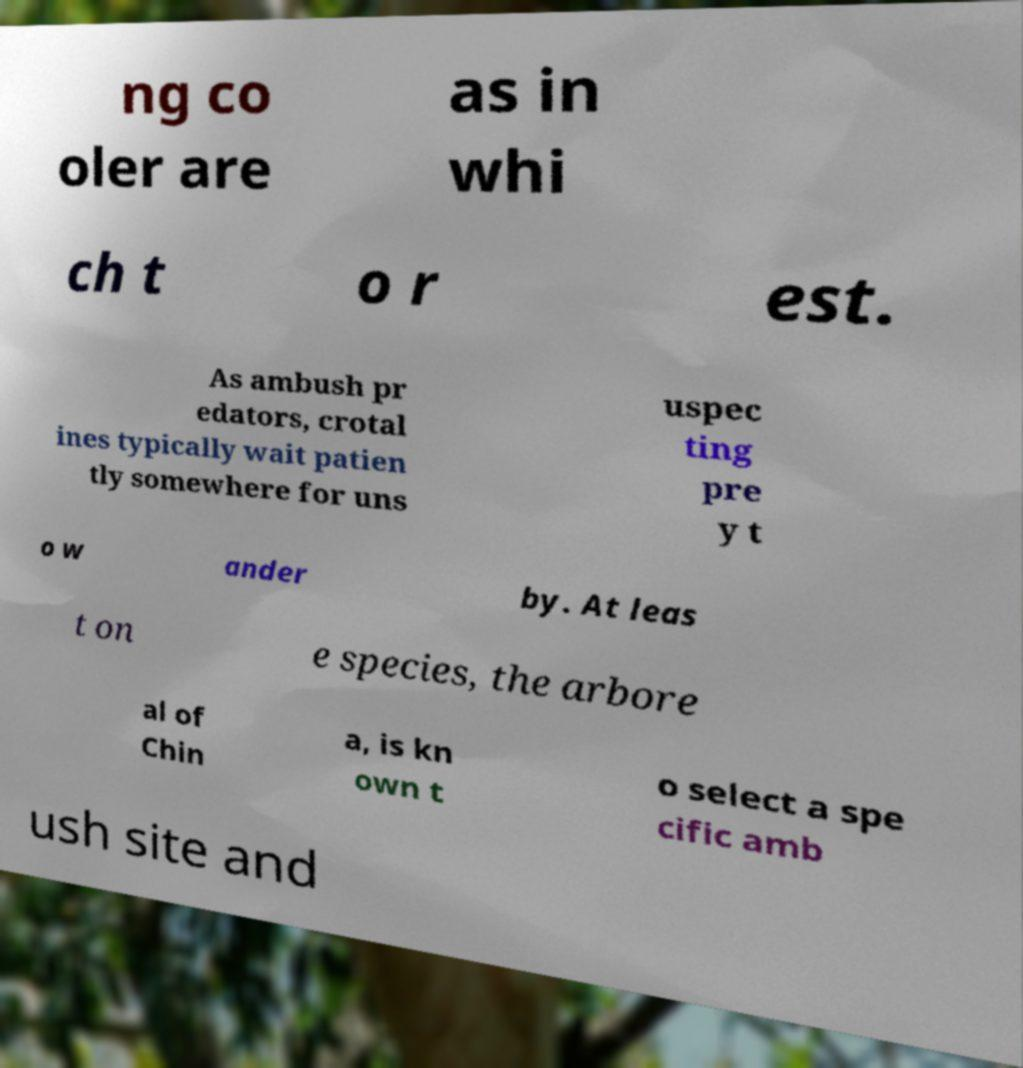There's text embedded in this image that I need extracted. Can you transcribe it verbatim? ng co oler are as in whi ch t o r est. As ambush pr edators, crotal ines typically wait patien tly somewhere for uns uspec ting pre y t o w ander by. At leas t on e species, the arbore al of Chin a, is kn own t o select a spe cific amb ush site and 